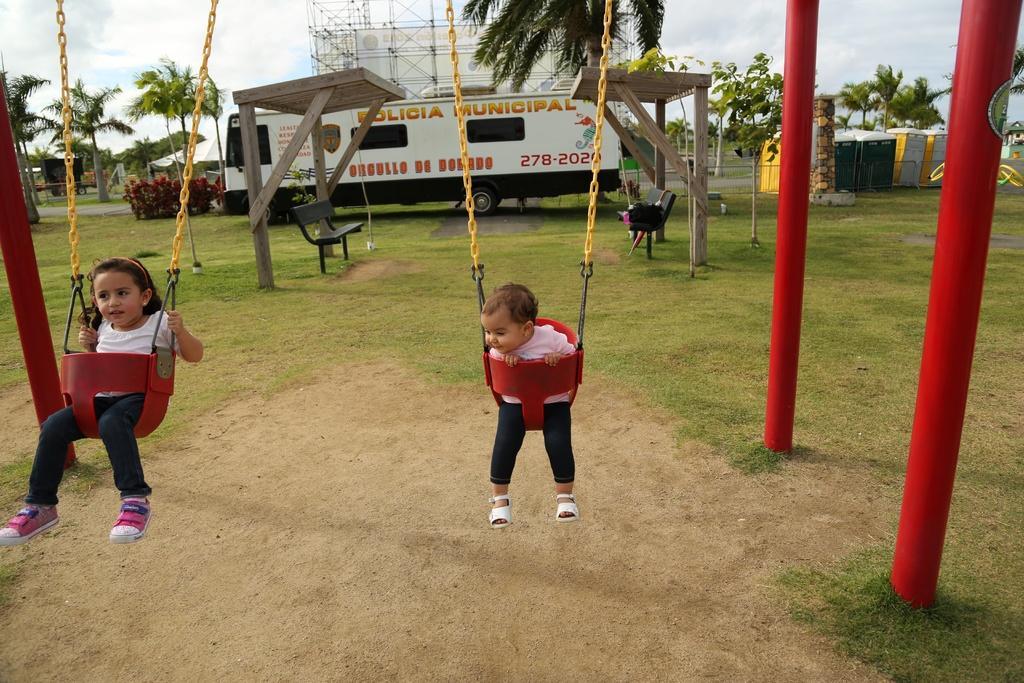Please provide a concise description of this image. In this image, we can see a few people sitting on objects. We can see the ground. We can see some grass, plants and trees. We can see some vehicles. We can see the wooden sheds. We can see some benches. There are some objects on the ground. We can also see a rock pillar. We can see a tower and a hoarding. We can see the sky with clouds. 